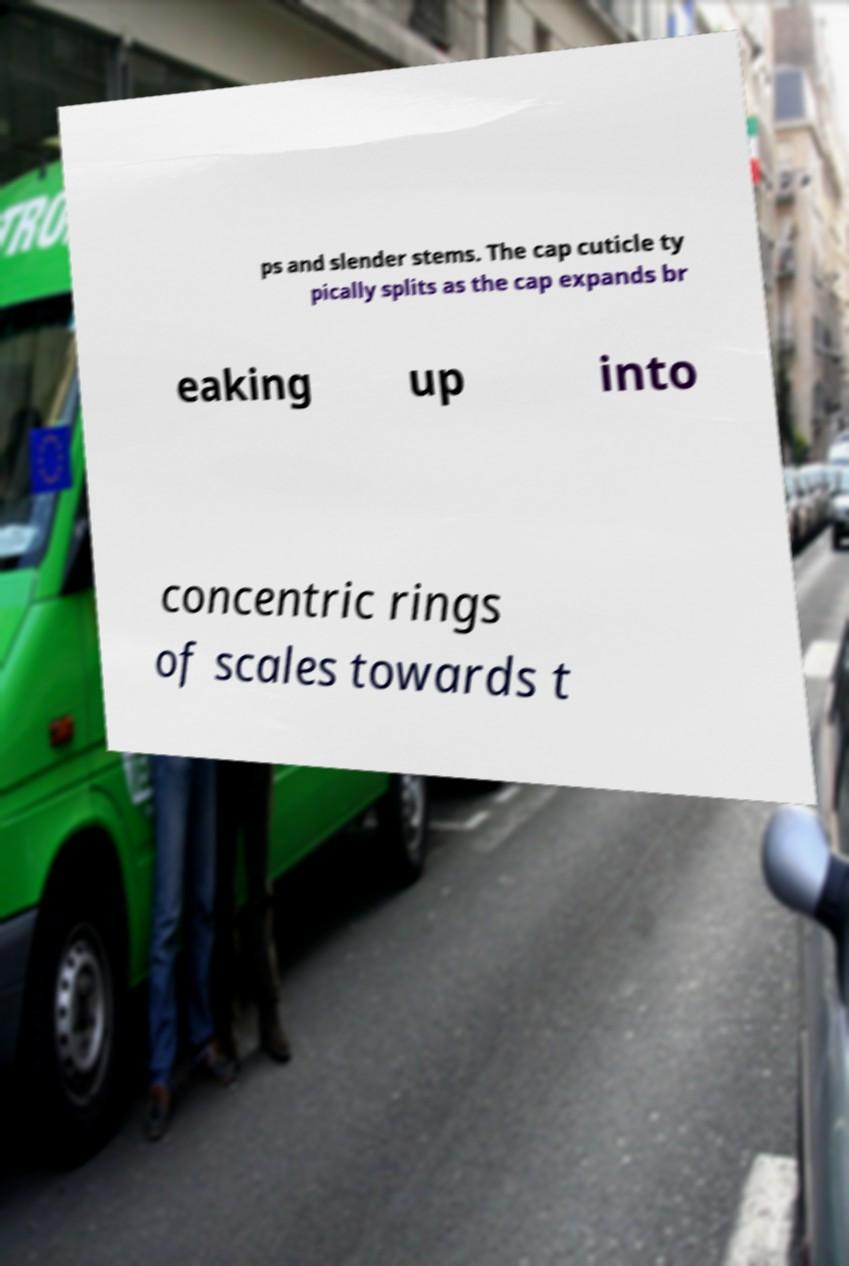Please read and relay the text visible in this image. What does it say? ps and slender stems. The cap cuticle ty pically splits as the cap expands br eaking up into concentric rings of scales towards t 